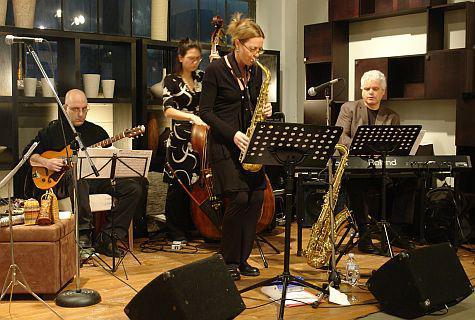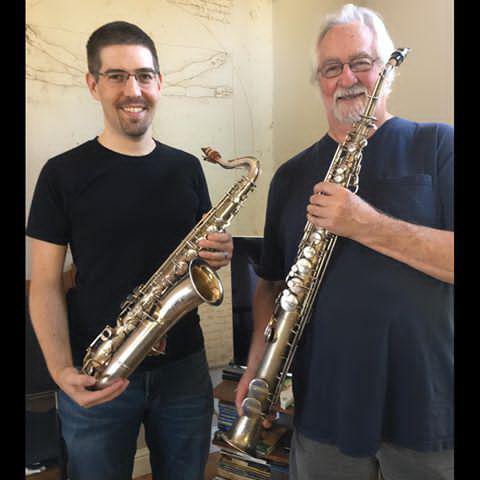The first image is the image on the left, the second image is the image on the right. For the images displayed, is the sentence "An image shows two men side-by-side holding instruments, and at least one of them wears a black short-sleeved t-shirt." factually correct? Answer yes or no. Yes. The first image is the image on the left, the second image is the image on the right. For the images displayed, is the sentence "In one image, a man with a music stand near him sits and plays a guitar while another person wearing glasses is playing at least one saxophone." factually correct? Answer yes or no. Yes. 